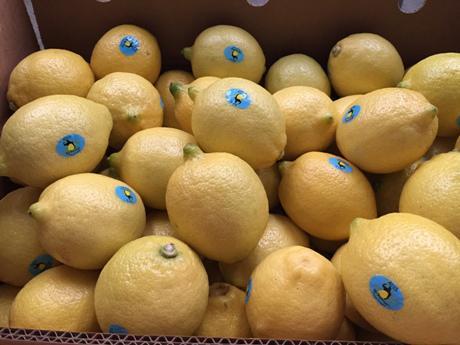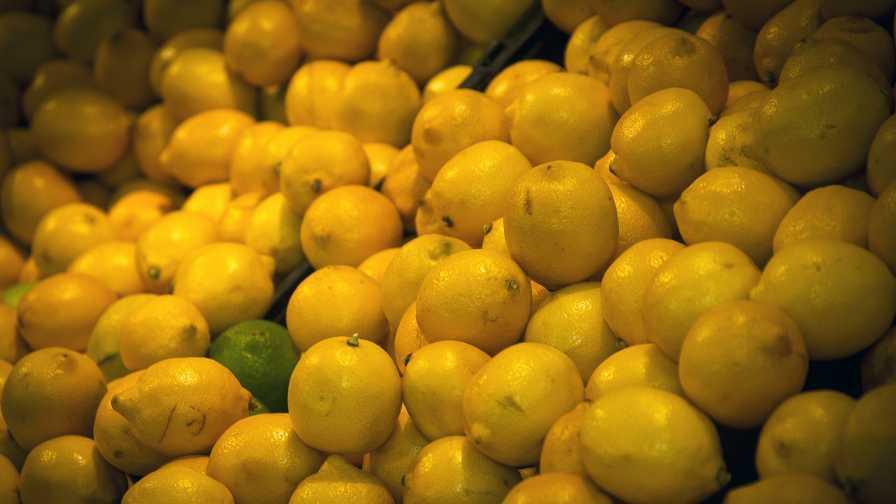The first image is the image on the left, the second image is the image on the right. Analyze the images presented: Is the assertion "In at least one image there is a box of lemons with at least six that have blue stickers." valid? Answer yes or no. Yes. 